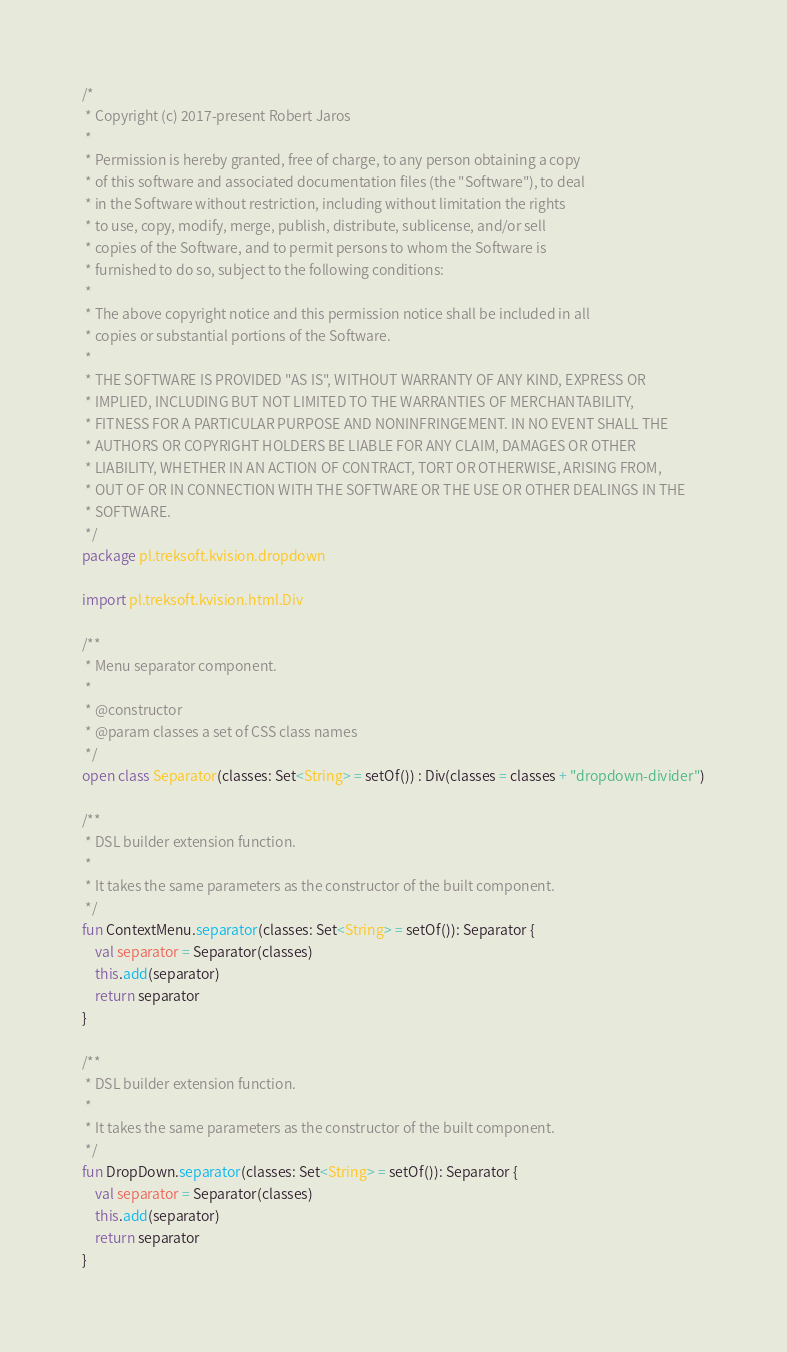Convert code to text. <code><loc_0><loc_0><loc_500><loc_500><_Kotlin_>/*
 * Copyright (c) 2017-present Robert Jaros
 *
 * Permission is hereby granted, free of charge, to any person obtaining a copy
 * of this software and associated documentation files (the "Software"), to deal
 * in the Software without restriction, including without limitation the rights
 * to use, copy, modify, merge, publish, distribute, sublicense, and/or sell
 * copies of the Software, and to permit persons to whom the Software is
 * furnished to do so, subject to the following conditions:
 *
 * The above copyright notice and this permission notice shall be included in all
 * copies or substantial portions of the Software.
 *
 * THE SOFTWARE IS PROVIDED "AS IS", WITHOUT WARRANTY OF ANY KIND, EXPRESS OR
 * IMPLIED, INCLUDING BUT NOT LIMITED TO THE WARRANTIES OF MERCHANTABILITY,
 * FITNESS FOR A PARTICULAR PURPOSE AND NONINFRINGEMENT. IN NO EVENT SHALL THE
 * AUTHORS OR COPYRIGHT HOLDERS BE LIABLE FOR ANY CLAIM, DAMAGES OR OTHER
 * LIABILITY, WHETHER IN AN ACTION OF CONTRACT, TORT OR OTHERWISE, ARISING FROM,
 * OUT OF OR IN CONNECTION WITH THE SOFTWARE OR THE USE OR OTHER DEALINGS IN THE
 * SOFTWARE.
 */
package pl.treksoft.kvision.dropdown

import pl.treksoft.kvision.html.Div

/**
 * Menu separator component.
 *
 * @constructor
 * @param classes a set of CSS class names
 */
open class Separator(classes: Set<String> = setOf()) : Div(classes = classes + "dropdown-divider")

/**
 * DSL builder extension function.
 *
 * It takes the same parameters as the constructor of the built component.
 */
fun ContextMenu.separator(classes: Set<String> = setOf()): Separator {
    val separator = Separator(classes)
    this.add(separator)
    return separator
}

/**
 * DSL builder extension function.
 *
 * It takes the same parameters as the constructor of the built component.
 */
fun DropDown.separator(classes: Set<String> = setOf()): Separator {
    val separator = Separator(classes)
    this.add(separator)
    return separator
}
</code> 